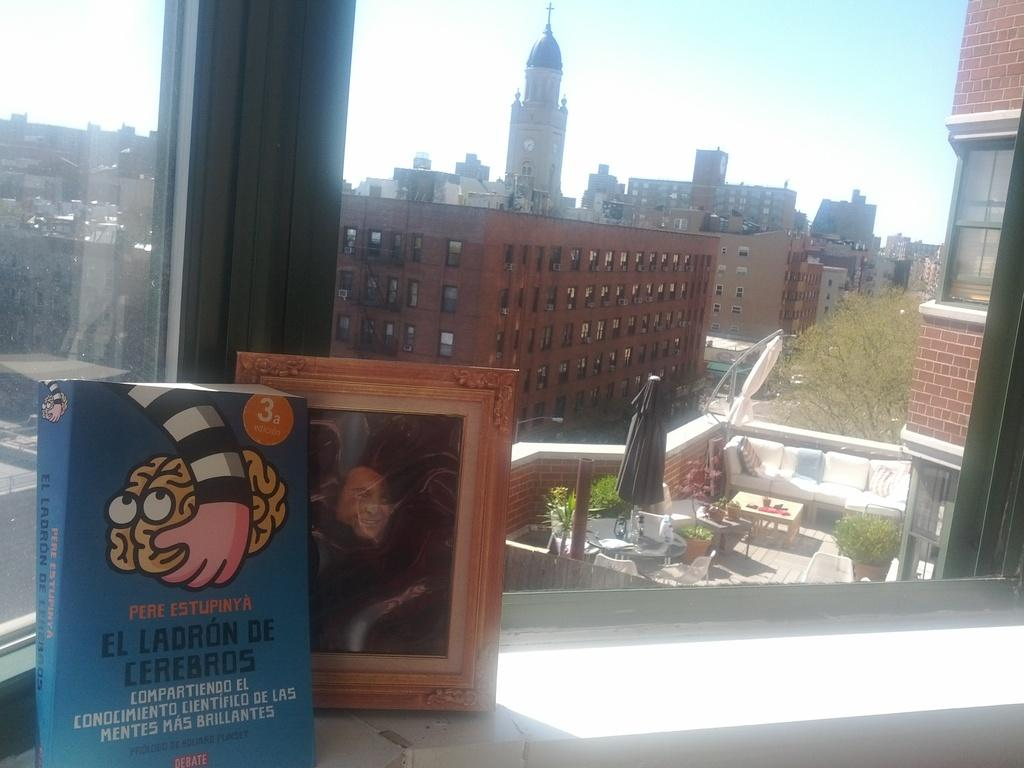What type of structures can be seen in the image? There are buildings in the image. What architectural features are visible on the buildings? There are windows visible on the buildings. What type of furniture is present in the image? There are sofas and tables in the image. What type of vegetation is present in the image? There are trees in the image. What type of decorative item can be seen in the image? There is a photo frame in the image. What type of object can be seen for reading or learning? There is a book in the image. What is visible at the top of the image? The sky is visible at the top of the image. How much profit does the toad in the image generate? There is no toad present in the image, so it is not possible to determine any profit generated. What type of paste is used to stick the book to the table in the image? There is no paste visible in the image, and the book is not stuck to the table. 